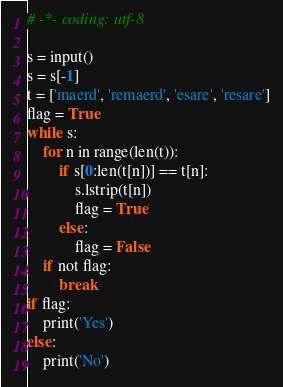Convert code to text. <code><loc_0><loc_0><loc_500><loc_500><_Python_># -*- coding: utf-8

s = input()
s = s[-1]
t = ['maerd', 'remaerd', 'esare', 'resare']
flag = True
while s:
    for n in range(len(t)):
        if s[0:len(t[n])] == t[n]:
            s.lstrip(t[n])
            flag = True
        else:
            flag = False
    if not flag:
        break
if flag:
    print('Yes')
else:
    print('No')</code> 